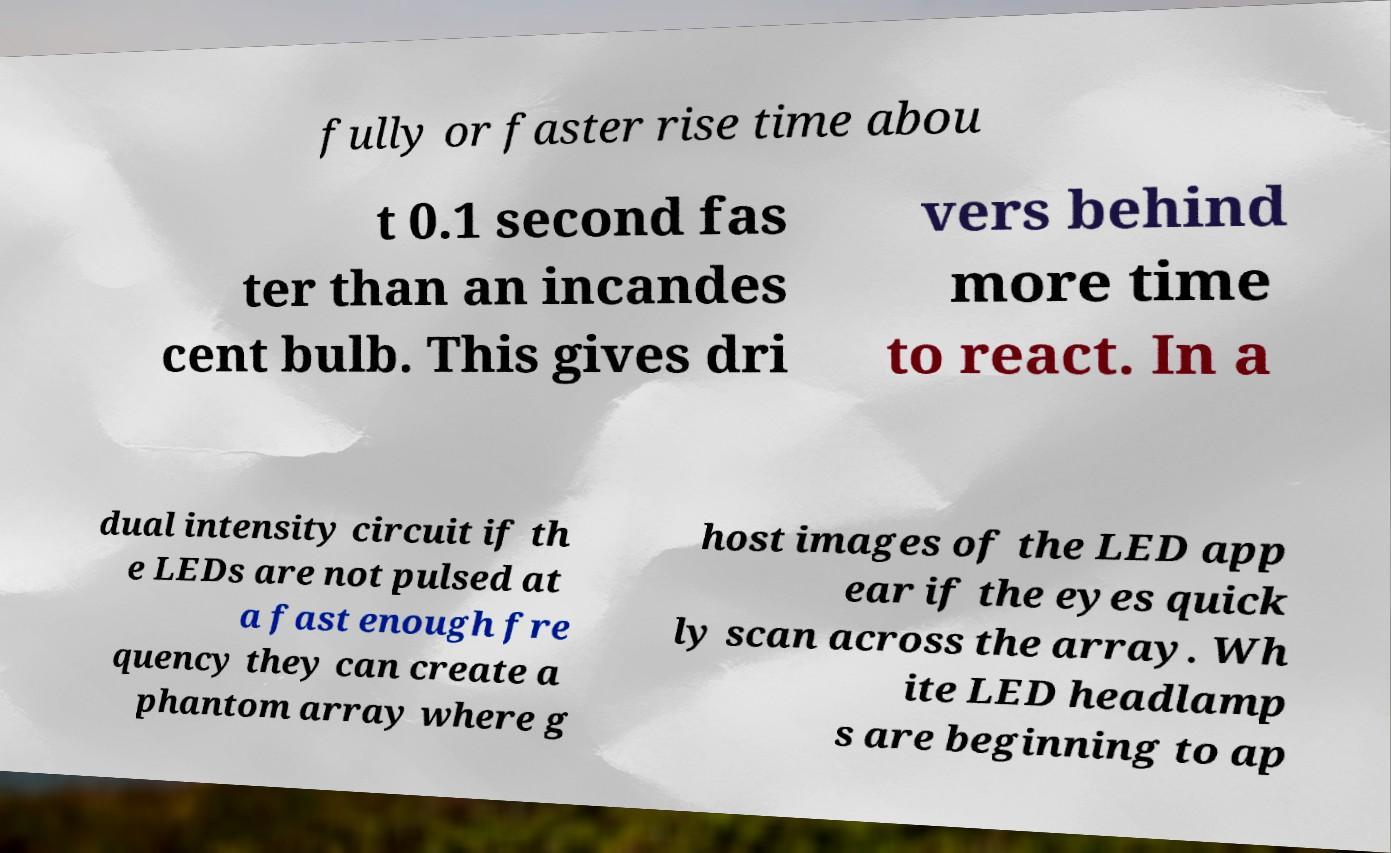What messages or text are displayed in this image? I need them in a readable, typed format. fully or faster rise time abou t 0.1 second fas ter than an incandes cent bulb. This gives dri vers behind more time to react. In a dual intensity circuit if th e LEDs are not pulsed at a fast enough fre quency they can create a phantom array where g host images of the LED app ear if the eyes quick ly scan across the array. Wh ite LED headlamp s are beginning to ap 